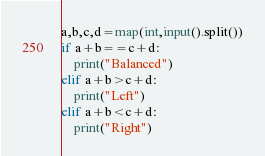<code> <loc_0><loc_0><loc_500><loc_500><_Python_>a,b,c,d=map(int,input().split())
if a+b==c+d:
    print("Balanced")
elif a+b>c+d:
    print("Left")
elif a+b<c+d:
    print("Right")</code> 